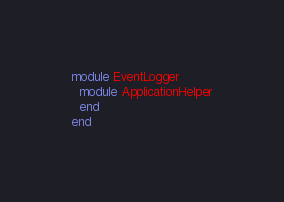Convert code to text. <code><loc_0><loc_0><loc_500><loc_500><_Ruby_>module EventLogger
  module ApplicationHelper
  end
end
</code> 